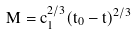Convert formula to latex. <formula><loc_0><loc_0><loc_500><loc_500>M = c _ { 1 } ^ { 2 / 3 } ( t _ { 0 } - t ) ^ { 2 / 3 }</formula> 